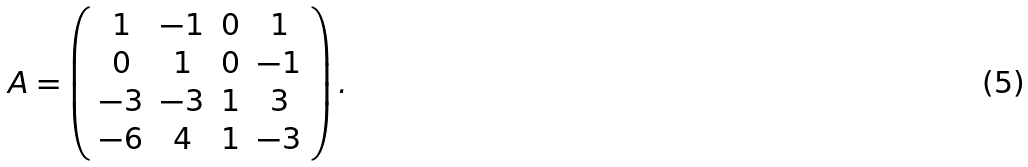<formula> <loc_0><loc_0><loc_500><loc_500>A = \left ( \begin{array} { c c c c } 1 & - 1 & 0 & 1 \\ 0 & 1 & 0 & - 1 \\ - 3 & - 3 & 1 & 3 \\ - 6 & 4 & 1 & - 3 \\ \end{array} \right ) .</formula> 